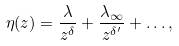Convert formula to latex. <formula><loc_0><loc_0><loc_500><loc_500>\eta ( z ) = \frac { \lambda } { z ^ { \delta } } + \frac { \lambda _ { \infty } } { z ^ { \delta ^ { \prime } } } + \dots ,</formula> 